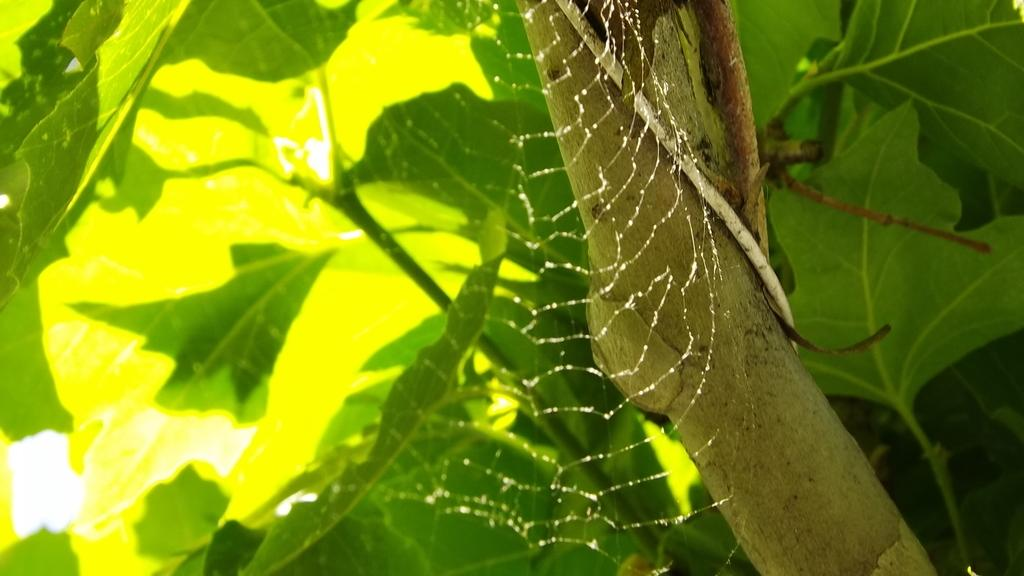What type of plant material can be seen in the image? There are leaves, a branch, and stems in the image. What is the connection between the leaves, branch, and stems in the image? They are all part of a plant or tree. What additional feature can be seen in the image? There is a spider web in the image. What type of lunch is the spider having in the image? There is no spider or lunch present in the image. What is the weather like in the image? The provided facts do not mention the weather, so it cannot be determined from the image. 